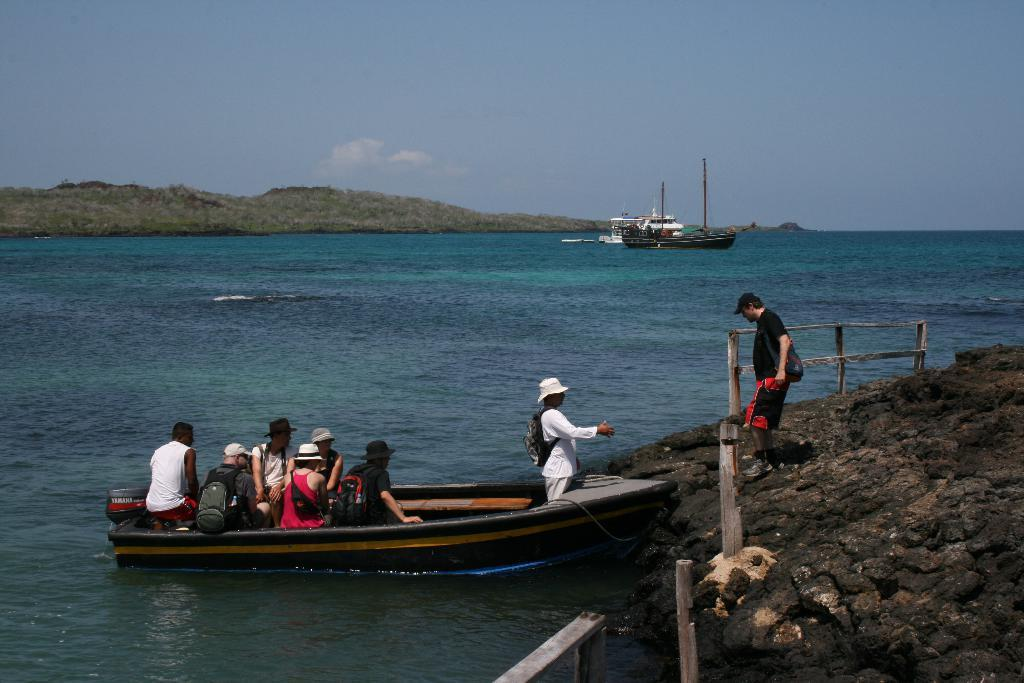What are the people in the image doing? The people in the image are sitting in a boat. What are the people wearing on their bodies? Two of the people are wearing bags. What can be seen above the water in the image? There are ships and boats visible above the water. What type of vegetation is visible in the background? The background includes grass. What is visible in the sky in the image? The sky is visible in the background. Where is the nearest airport to the boat in the image? There is no information about an airport in the image, as it focuses on people sitting in a boat and the surrounding environment. 